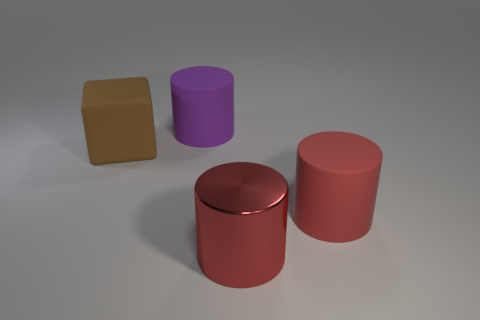Subtract all big metallic cylinders. How many cylinders are left? 2 Add 2 big red metal objects. How many objects exist? 6 Subtract 1 blocks. How many blocks are left? 0 Subtract all red cylinders. How many cylinders are left? 1 Subtract all cylinders. How many objects are left? 1 Add 2 large red metal things. How many large red metal things exist? 3 Subtract 0 cyan cubes. How many objects are left? 4 Subtract all yellow cylinders. Subtract all red balls. How many cylinders are left? 3 Subtract all purple blocks. How many purple cylinders are left? 1 Subtract all brown matte things. Subtract all brown rubber things. How many objects are left? 2 